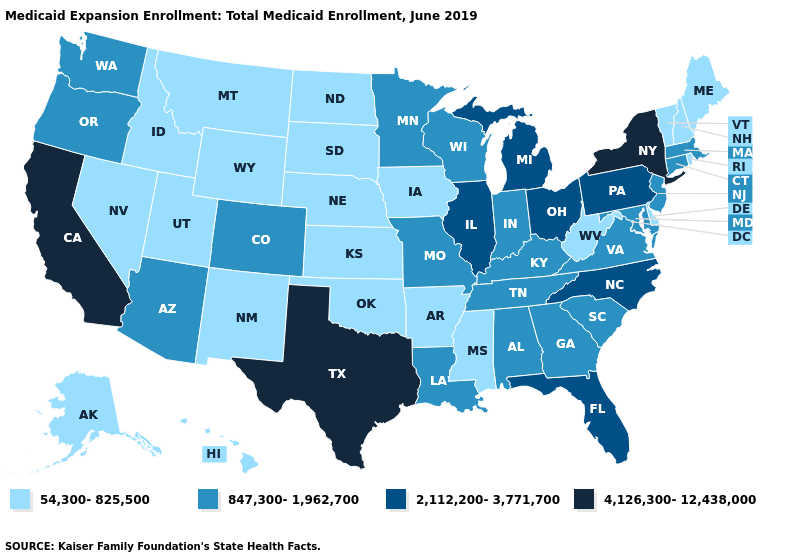What is the value of Wisconsin?
Be succinct. 847,300-1,962,700. Name the states that have a value in the range 54,300-825,500?
Give a very brief answer. Alaska, Arkansas, Delaware, Hawaii, Idaho, Iowa, Kansas, Maine, Mississippi, Montana, Nebraska, Nevada, New Hampshire, New Mexico, North Dakota, Oklahoma, Rhode Island, South Dakota, Utah, Vermont, West Virginia, Wyoming. Name the states that have a value in the range 847,300-1,962,700?
Keep it brief. Alabama, Arizona, Colorado, Connecticut, Georgia, Indiana, Kentucky, Louisiana, Maryland, Massachusetts, Minnesota, Missouri, New Jersey, Oregon, South Carolina, Tennessee, Virginia, Washington, Wisconsin. Does Rhode Island have the same value as Michigan?
Answer briefly. No. How many symbols are there in the legend?
Give a very brief answer. 4. What is the value of Vermont?
Answer briefly. 54,300-825,500. What is the value of Mississippi?
Write a very short answer. 54,300-825,500. Does Alabama have the highest value in the USA?
Quick response, please. No. What is the value of Arkansas?
Write a very short answer. 54,300-825,500. Which states hav the highest value in the Northeast?
Short answer required. New York. Name the states that have a value in the range 54,300-825,500?
Keep it brief. Alaska, Arkansas, Delaware, Hawaii, Idaho, Iowa, Kansas, Maine, Mississippi, Montana, Nebraska, Nevada, New Hampshire, New Mexico, North Dakota, Oklahoma, Rhode Island, South Dakota, Utah, Vermont, West Virginia, Wyoming. What is the value of Mississippi?
Keep it brief. 54,300-825,500. Does Washington have the lowest value in the West?
Be succinct. No. Name the states that have a value in the range 847,300-1,962,700?
Write a very short answer. Alabama, Arizona, Colorado, Connecticut, Georgia, Indiana, Kentucky, Louisiana, Maryland, Massachusetts, Minnesota, Missouri, New Jersey, Oregon, South Carolina, Tennessee, Virginia, Washington, Wisconsin. What is the value of New York?
Quick response, please. 4,126,300-12,438,000. 